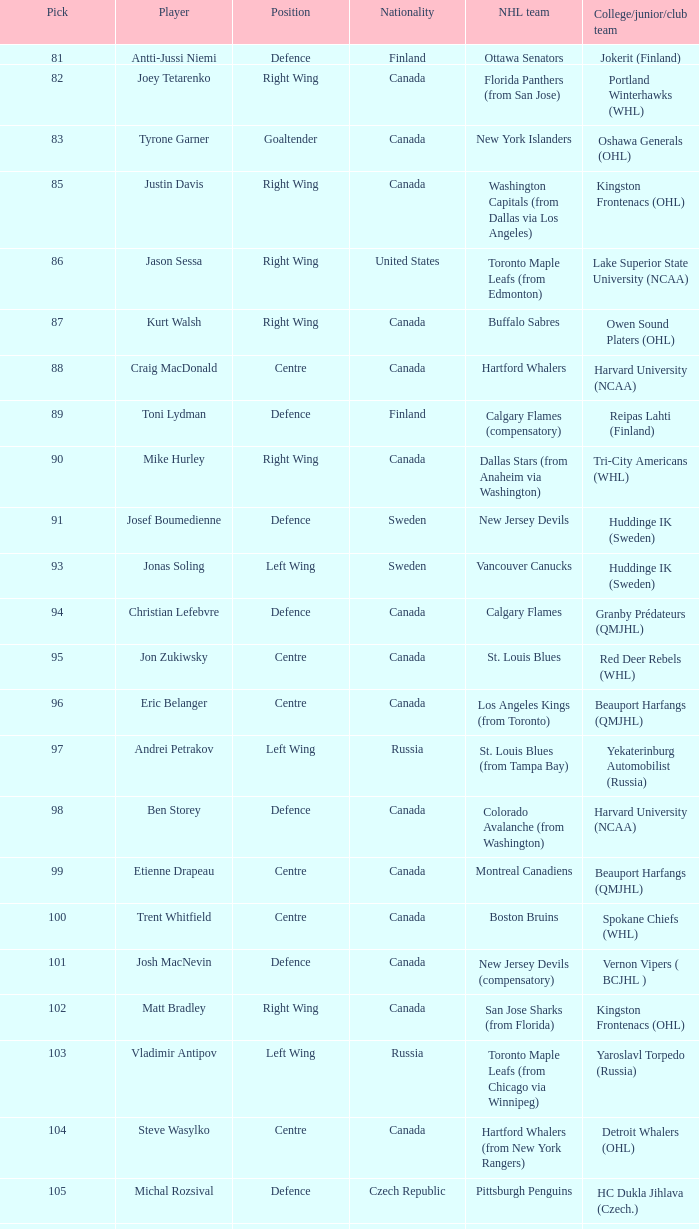How many players were part of the college team reipas lahti (finland)? 1.0. 